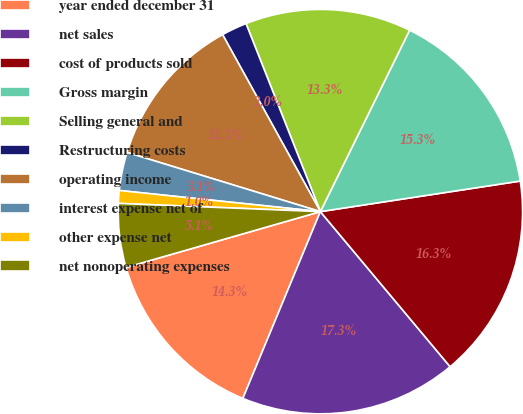<chart> <loc_0><loc_0><loc_500><loc_500><pie_chart><fcel>year ended december 31<fcel>net sales<fcel>cost of products sold<fcel>Gross margin<fcel>Selling general and<fcel>Restructuring costs<fcel>operating income<fcel>interest expense net of<fcel>other expense net<fcel>net nonoperating expenses<nl><fcel>14.29%<fcel>17.35%<fcel>16.33%<fcel>15.31%<fcel>13.27%<fcel>2.04%<fcel>12.24%<fcel>3.06%<fcel>1.02%<fcel>5.1%<nl></chart> 